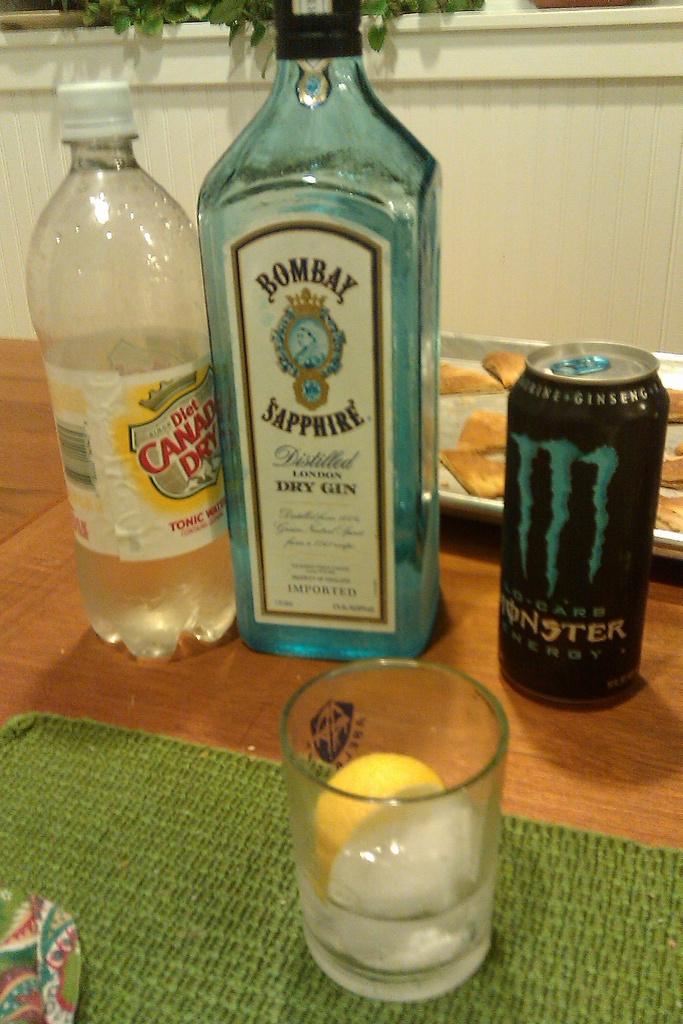What spirit is this?
Keep it short and to the point. Gin. 